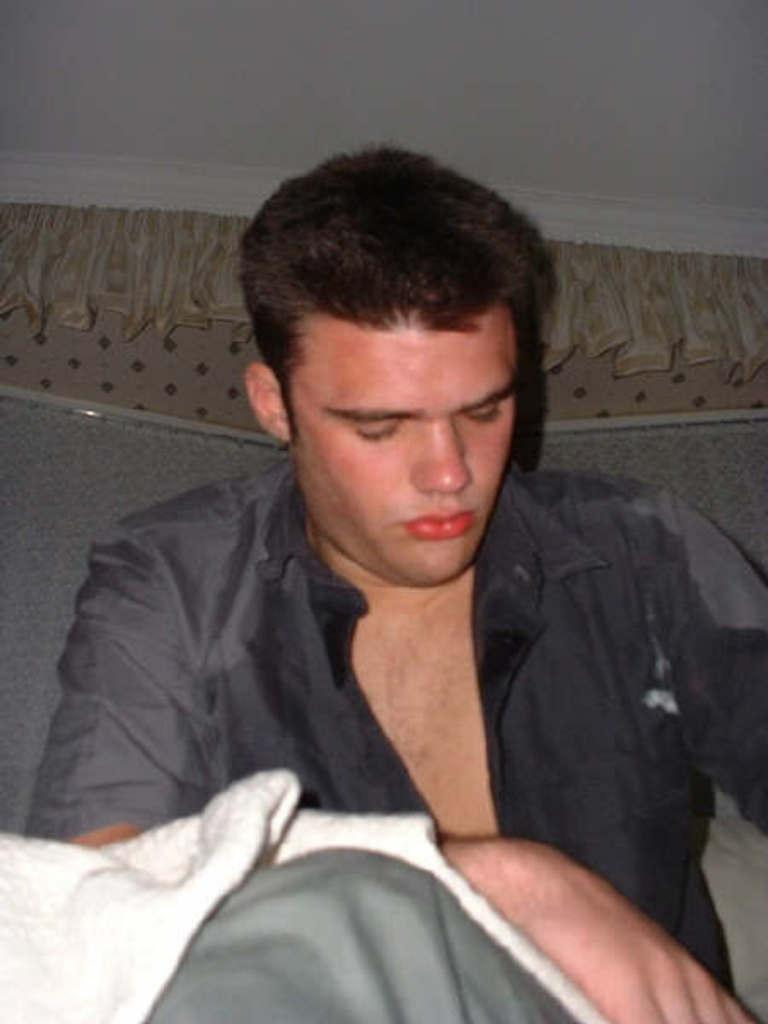Who is present in the image? There is a man in the image. What is the man wearing? The man is wearing a dark color shirt. What else can be seen in the image besides the man? There is a white color cloth in the image. What type of polish is the man applying to the dinosaurs in the image? There are no dinosaurs or polish present in the image. How deep is the mine that the man is working in the image? There is no mine present in the image. 